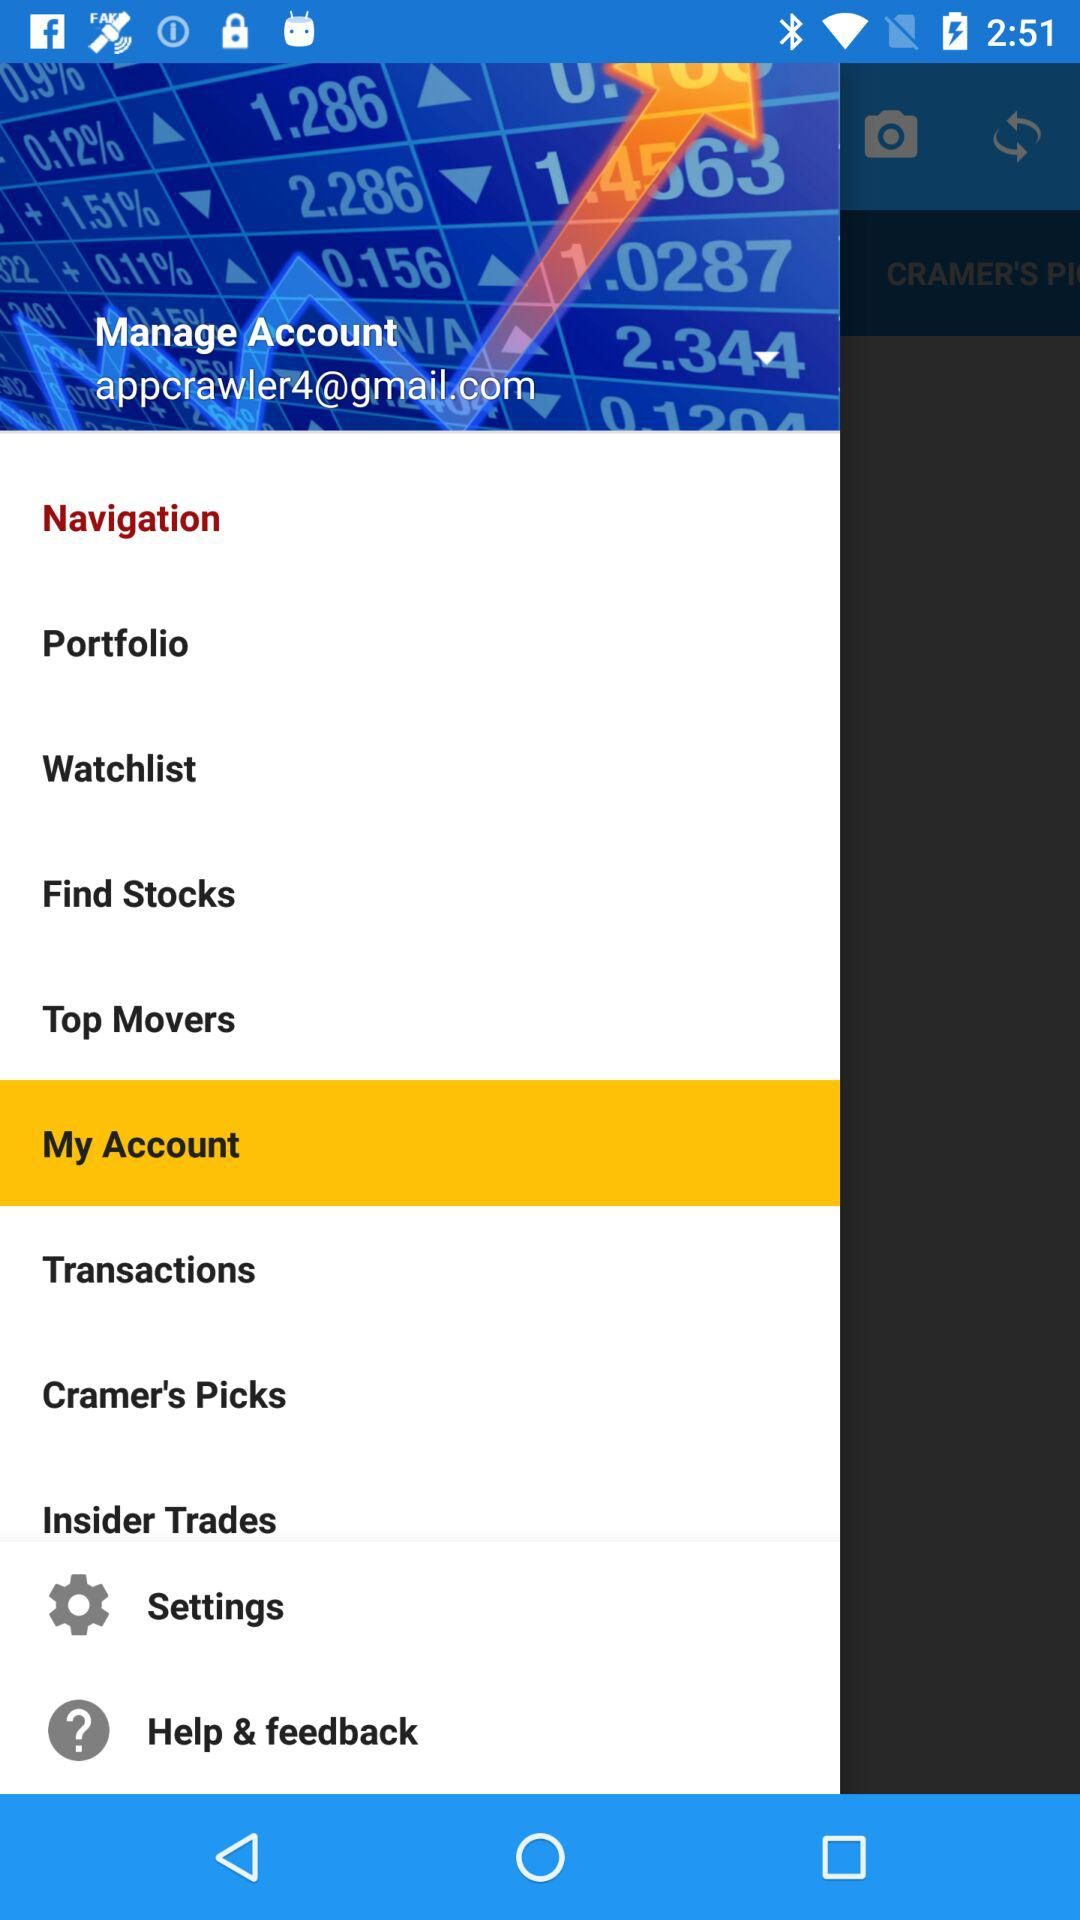What email address is used to manage the account? The used email address is appcrawler4@gmail.com. 